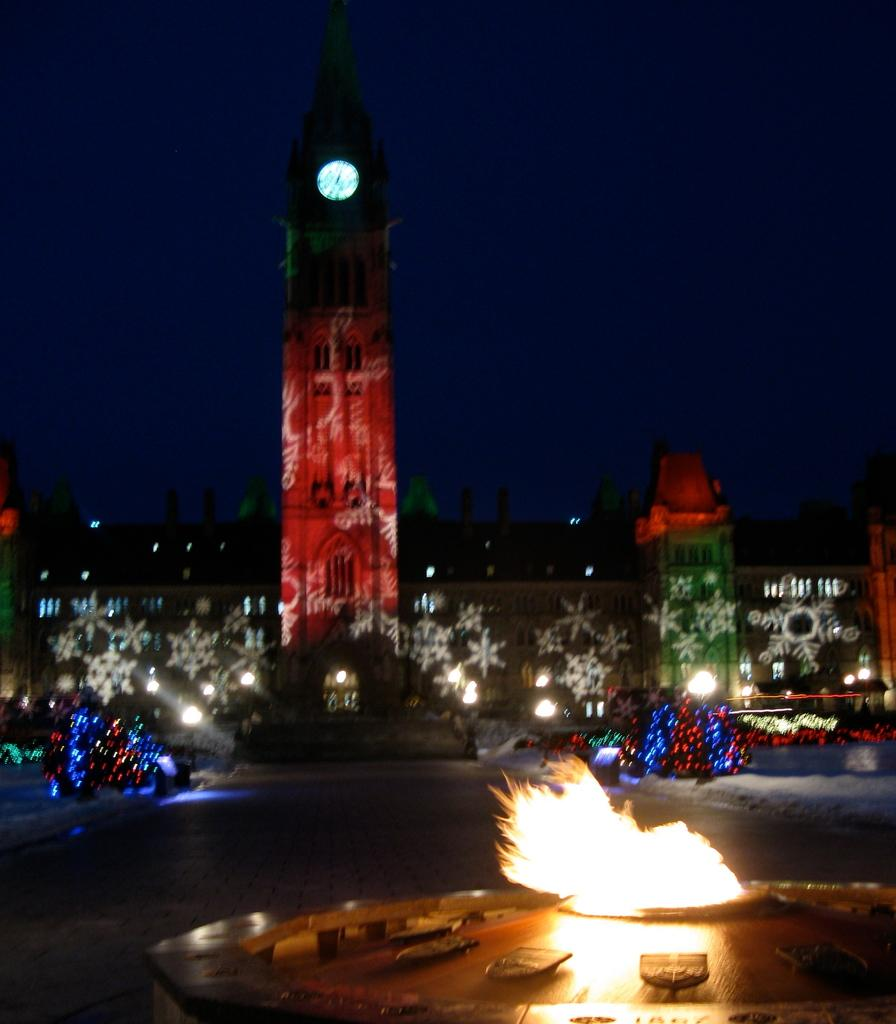What type of structure can be seen in the image? There is a building and a tower in the image. What is happening in the image? There is fire in the image. What type of pathways are present in the image? There are roads in the image. What is visible in the background of the image? The sky is visible in the image. What type of lighting is present in the image? Electric lights are present in the image. How many cows can be seen grazing on the border in the image? There are no cows or borders present in the image. What form does the fire take in the image? The fire in the image does not have a specific form; it is depicted as flames. 